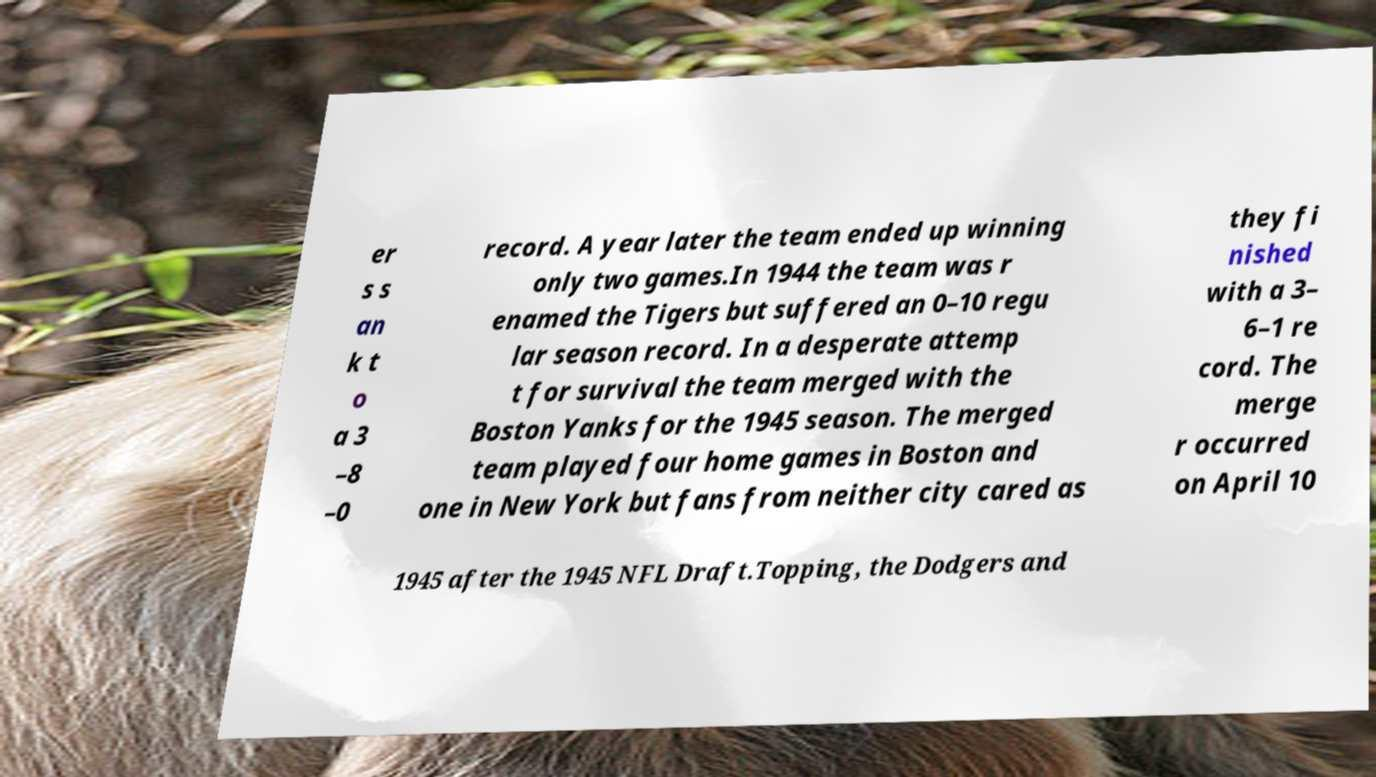There's text embedded in this image that I need extracted. Can you transcribe it verbatim? er s s an k t o a 3 –8 –0 record. A year later the team ended up winning only two games.In 1944 the team was r enamed the Tigers but suffered an 0–10 regu lar season record. In a desperate attemp t for survival the team merged with the Boston Yanks for the 1945 season. The merged team played four home games in Boston and one in New York but fans from neither city cared as they fi nished with a 3– 6–1 re cord. The merge r occurred on April 10 1945 after the 1945 NFL Draft.Topping, the Dodgers and 